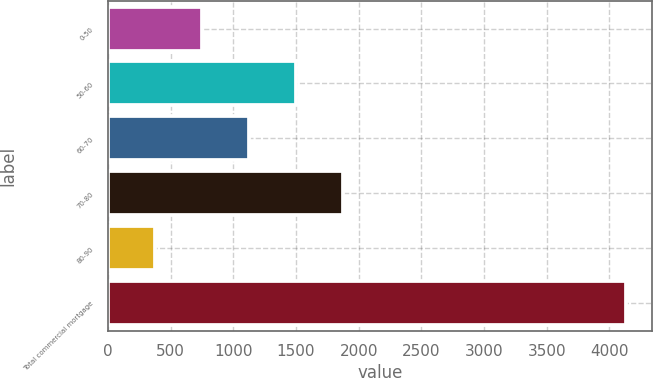Convert chart to OTSL. <chart><loc_0><loc_0><loc_500><loc_500><bar_chart><fcel>0-50<fcel>50-60<fcel>60-70<fcel>70-80<fcel>80-90<fcel>Total commercial mortgage<nl><fcel>748.8<fcel>1500.4<fcel>1124.6<fcel>1876.2<fcel>373<fcel>4131<nl></chart> 